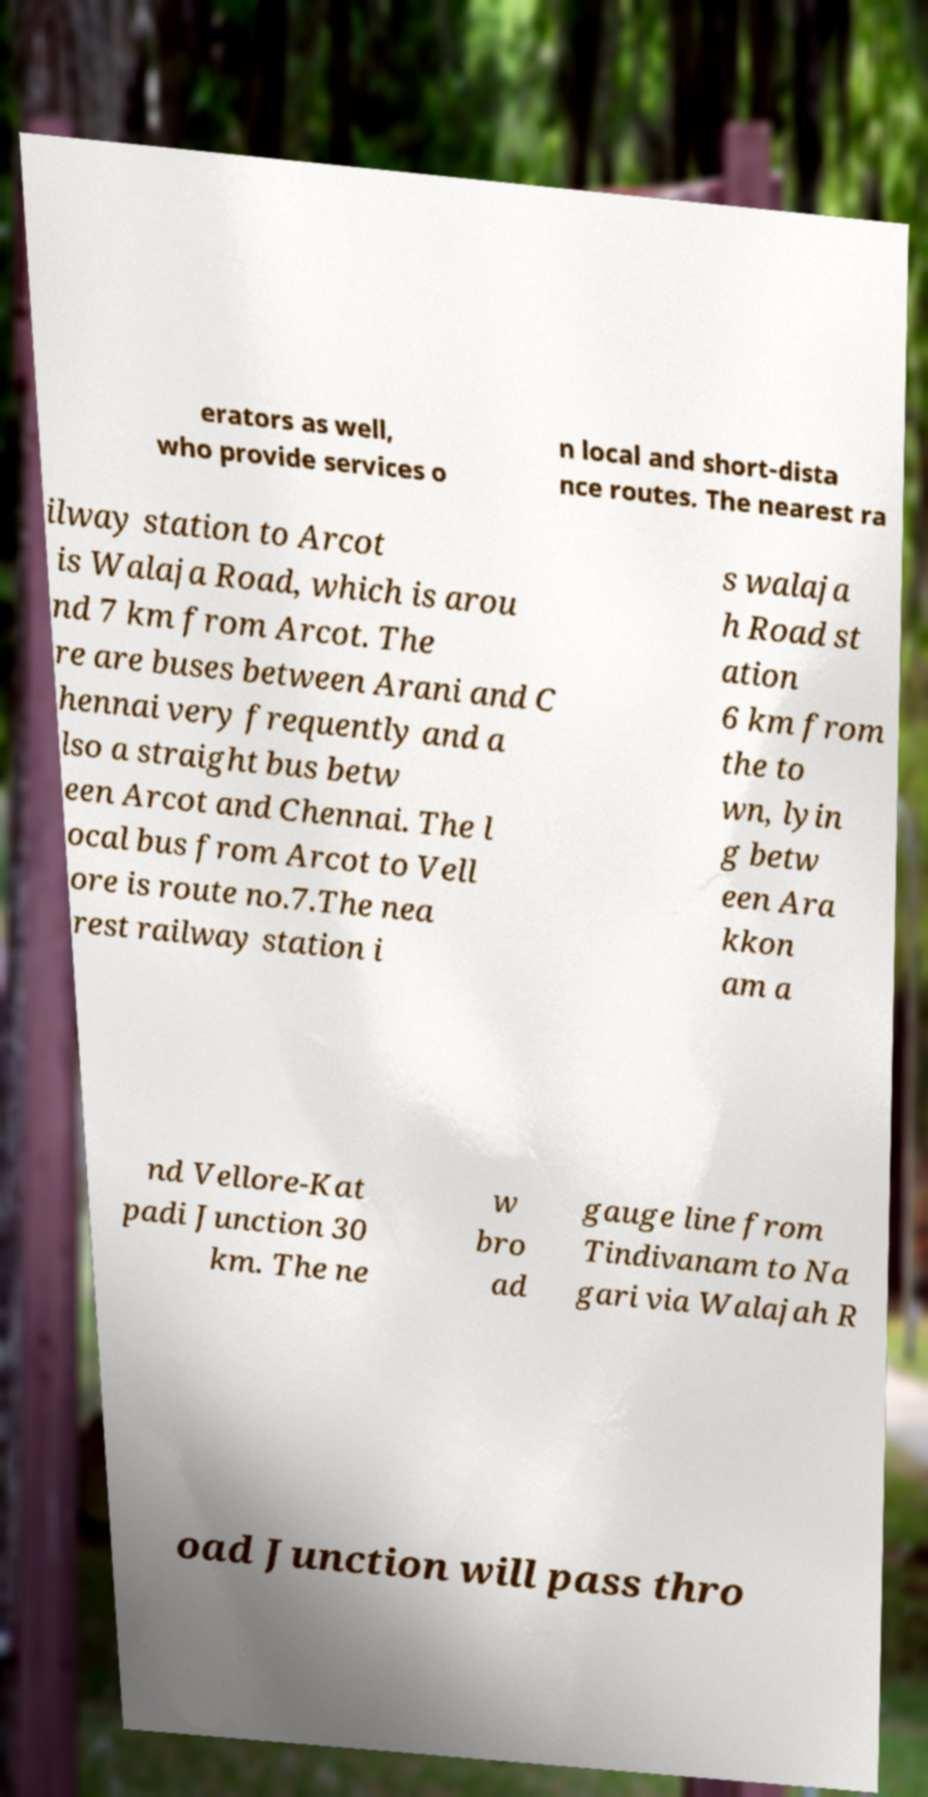Please read and relay the text visible in this image. What does it say? erators as well, who provide services o n local and short-dista nce routes. The nearest ra ilway station to Arcot is Walaja Road, which is arou nd 7 km from Arcot. The re are buses between Arani and C hennai very frequently and a lso a straight bus betw een Arcot and Chennai. The l ocal bus from Arcot to Vell ore is route no.7.The nea rest railway station i s walaja h Road st ation 6 km from the to wn, lyin g betw een Ara kkon am a nd Vellore-Kat padi Junction 30 km. The ne w bro ad gauge line from Tindivanam to Na gari via Walajah R oad Junction will pass thro 